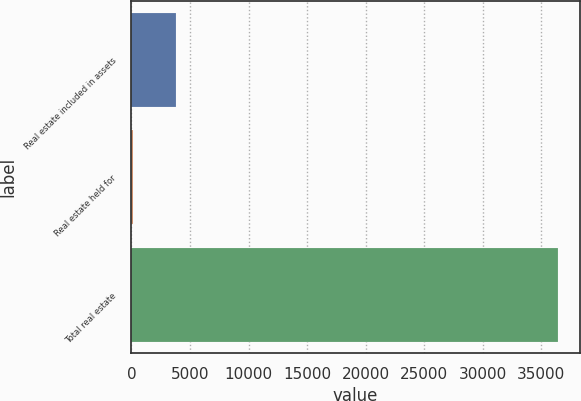<chart> <loc_0><loc_0><loc_500><loc_500><bar_chart><fcel>Real estate included in assets<fcel>Real estate held for<fcel>Total real estate<nl><fcel>3791<fcel>162<fcel>36452<nl></chart> 